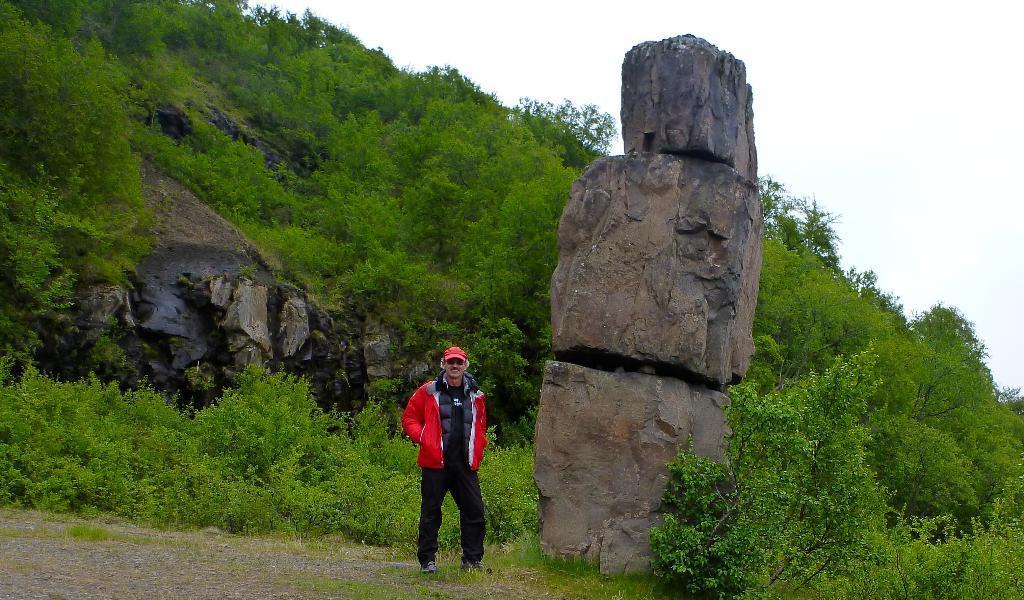How would you summarize this image in a sentence or two? In this image there is a person standing beside a big stone behind him there is a mountain with stones and plants. 